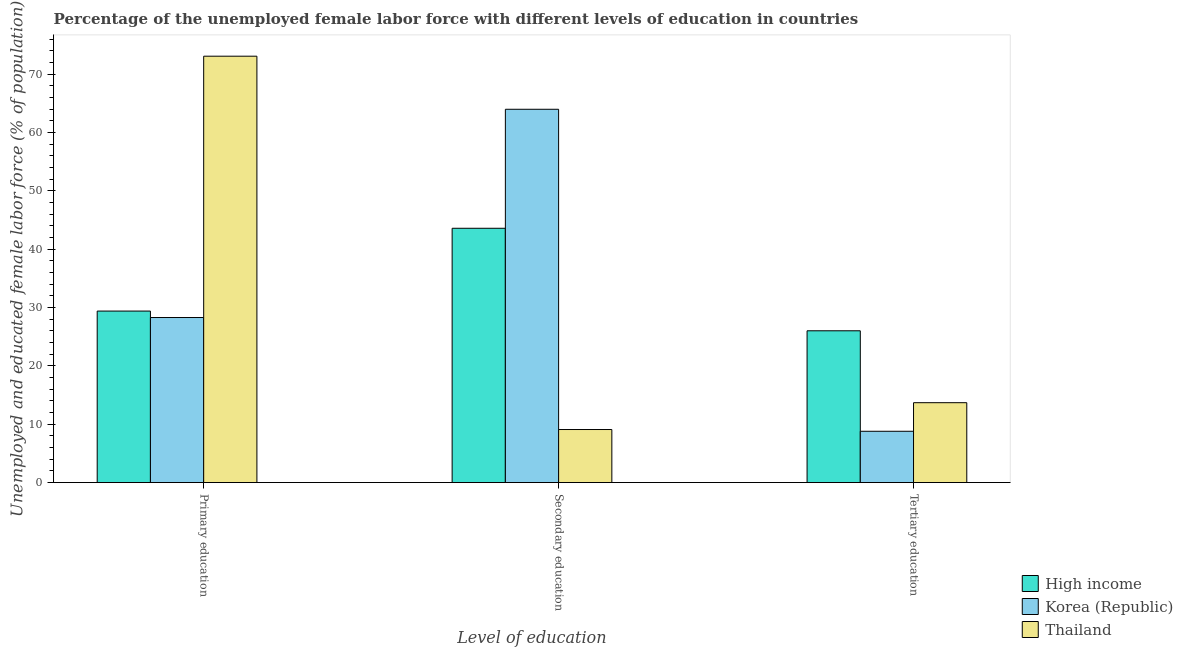How many groups of bars are there?
Your answer should be very brief. 3. How many bars are there on the 2nd tick from the left?
Your answer should be compact. 3. How many bars are there on the 2nd tick from the right?
Offer a very short reply. 3. What is the label of the 3rd group of bars from the left?
Keep it short and to the point. Tertiary education. What is the percentage of female labor force who received primary education in High income?
Offer a terse response. 29.41. Across all countries, what is the maximum percentage of female labor force who received secondary education?
Your response must be concise. 64. Across all countries, what is the minimum percentage of female labor force who received secondary education?
Provide a succinct answer. 9.1. In which country was the percentage of female labor force who received tertiary education minimum?
Keep it short and to the point. Korea (Republic). What is the total percentage of female labor force who received secondary education in the graph?
Your answer should be compact. 116.7. What is the difference between the percentage of female labor force who received secondary education in High income and that in Korea (Republic)?
Keep it short and to the point. -20.4. What is the difference between the percentage of female labor force who received tertiary education in Korea (Republic) and the percentage of female labor force who received secondary education in Thailand?
Give a very brief answer. -0.3. What is the average percentage of female labor force who received tertiary education per country?
Your response must be concise. 16.18. What is the difference between the percentage of female labor force who received secondary education and percentage of female labor force who received tertiary education in High income?
Offer a very short reply. 17.57. In how many countries, is the percentage of female labor force who received secondary education greater than 32 %?
Give a very brief answer. 2. What is the ratio of the percentage of female labor force who received tertiary education in Korea (Republic) to that in Thailand?
Offer a very short reply. 0.64. Is the percentage of female labor force who received tertiary education in Korea (Republic) less than that in High income?
Make the answer very short. Yes. What is the difference between the highest and the second highest percentage of female labor force who received secondary education?
Make the answer very short. 20.4. What is the difference between the highest and the lowest percentage of female labor force who received tertiary education?
Offer a terse response. 17.23. In how many countries, is the percentage of female labor force who received tertiary education greater than the average percentage of female labor force who received tertiary education taken over all countries?
Ensure brevity in your answer.  1. Is the sum of the percentage of female labor force who received secondary education in High income and Thailand greater than the maximum percentage of female labor force who received tertiary education across all countries?
Give a very brief answer. Yes. What does the 3rd bar from the left in Secondary education represents?
Keep it short and to the point. Thailand. How many bars are there?
Give a very brief answer. 9. Are the values on the major ticks of Y-axis written in scientific E-notation?
Your answer should be compact. No. Does the graph contain any zero values?
Make the answer very short. No. Does the graph contain grids?
Provide a succinct answer. No. How many legend labels are there?
Your response must be concise. 3. How are the legend labels stacked?
Your response must be concise. Vertical. What is the title of the graph?
Make the answer very short. Percentage of the unemployed female labor force with different levels of education in countries. Does "Jamaica" appear as one of the legend labels in the graph?
Keep it short and to the point. No. What is the label or title of the X-axis?
Offer a very short reply. Level of education. What is the label or title of the Y-axis?
Make the answer very short. Unemployed and educated female labor force (% of population). What is the Unemployed and educated female labor force (% of population) of High income in Primary education?
Keep it short and to the point. 29.41. What is the Unemployed and educated female labor force (% of population) in Korea (Republic) in Primary education?
Provide a short and direct response. 28.3. What is the Unemployed and educated female labor force (% of population) in Thailand in Primary education?
Ensure brevity in your answer.  73.1. What is the Unemployed and educated female labor force (% of population) in High income in Secondary education?
Your answer should be very brief. 43.6. What is the Unemployed and educated female labor force (% of population) of Korea (Republic) in Secondary education?
Provide a succinct answer. 64. What is the Unemployed and educated female labor force (% of population) in Thailand in Secondary education?
Ensure brevity in your answer.  9.1. What is the Unemployed and educated female labor force (% of population) of High income in Tertiary education?
Your answer should be compact. 26.03. What is the Unemployed and educated female labor force (% of population) in Korea (Republic) in Tertiary education?
Ensure brevity in your answer.  8.8. What is the Unemployed and educated female labor force (% of population) in Thailand in Tertiary education?
Offer a very short reply. 13.7. Across all Level of education, what is the maximum Unemployed and educated female labor force (% of population) of High income?
Your answer should be very brief. 43.6. Across all Level of education, what is the maximum Unemployed and educated female labor force (% of population) of Korea (Republic)?
Your response must be concise. 64. Across all Level of education, what is the maximum Unemployed and educated female labor force (% of population) in Thailand?
Keep it short and to the point. 73.1. Across all Level of education, what is the minimum Unemployed and educated female labor force (% of population) in High income?
Your response must be concise. 26.03. Across all Level of education, what is the minimum Unemployed and educated female labor force (% of population) of Korea (Republic)?
Offer a terse response. 8.8. Across all Level of education, what is the minimum Unemployed and educated female labor force (% of population) of Thailand?
Provide a short and direct response. 9.1. What is the total Unemployed and educated female labor force (% of population) of High income in the graph?
Your answer should be compact. 99.03. What is the total Unemployed and educated female labor force (% of population) of Korea (Republic) in the graph?
Provide a succinct answer. 101.1. What is the total Unemployed and educated female labor force (% of population) of Thailand in the graph?
Your response must be concise. 95.9. What is the difference between the Unemployed and educated female labor force (% of population) of High income in Primary education and that in Secondary education?
Your answer should be very brief. -14.19. What is the difference between the Unemployed and educated female labor force (% of population) in Korea (Republic) in Primary education and that in Secondary education?
Provide a succinct answer. -35.7. What is the difference between the Unemployed and educated female labor force (% of population) of Thailand in Primary education and that in Secondary education?
Offer a terse response. 64. What is the difference between the Unemployed and educated female labor force (% of population) in High income in Primary education and that in Tertiary education?
Keep it short and to the point. 3.38. What is the difference between the Unemployed and educated female labor force (% of population) in Thailand in Primary education and that in Tertiary education?
Your answer should be compact. 59.4. What is the difference between the Unemployed and educated female labor force (% of population) in High income in Secondary education and that in Tertiary education?
Your answer should be very brief. 17.57. What is the difference between the Unemployed and educated female labor force (% of population) of Korea (Republic) in Secondary education and that in Tertiary education?
Your answer should be compact. 55.2. What is the difference between the Unemployed and educated female labor force (% of population) of Thailand in Secondary education and that in Tertiary education?
Provide a short and direct response. -4.6. What is the difference between the Unemployed and educated female labor force (% of population) of High income in Primary education and the Unemployed and educated female labor force (% of population) of Korea (Republic) in Secondary education?
Your answer should be compact. -34.59. What is the difference between the Unemployed and educated female labor force (% of population) of High income in Primary education and the Unemployed and educated female labor force (% of population) of Thailand in Secondary education?
Provide a short and direct response. 20.31. What is the difference between the Unemployed and educated female labor force (% of population) of High income in Primary education and the Unemployed and educated female labor force (% of population) of Korea (Republic) in Tertiary education?
Your answer should be very brief. 20.61. What is the difference between the Unemployed and educated female labor force (% of population) in High income in Primary education and the Unemployed and educated female labor force (% of population) in Thailand in Tertiary education?
Your answer should be compact. 15.71. What is the difference between the Unemployed and educated female labor force (% of population) in Korea (Republic) in Primary education and the Unemployed and educated female labor force (% of population) in Thailand in Tertiary education?
Give a very brief answer. 14.6. What is the difference between the Unemployed and educated female labor force (% of population) in High income in Secondary education and the Unemployed and educated female labor force (% of population) in Korea (Republic) in Tertiary education?
Your answer should be very brief. 34.8. What is the difference between the Unemployed and educated female labor force (% of population) of High income in Secondary education and the Unemployed and educated female labor force (% of population) of Thailand in Tertiary education?
Your answer should be very brief. 29.9. What is the difference between the Unemployed and educated female labor force (% of population) in Korea (Republic) in Secondary education and the Unemployed and educated female labor force (% of population) in Thailand in Tertiary education?
Make the answer very short. 50.3. What is the average Unemployed and educated female labor force (% of population) in High income per Level of education?
Provide a succinct answer. 33.01. What is the average Unemployed and educated female labor force (% of population) of Korea (Republic) per Level of education?
Offer a very short reply. 33.7. What is the average Unemployed and educated female labor force (% of population) in Thailand per Level of education?
Make the answer very short. 31.97. What is the difference between the Unemployed and educated female labor force (% of population) of High income and Unemployed and educated female labor force (% of population) of Korea (Republic) in Primary education?
Make the answer very short. 1.11. What is the difference between the Unemployed and educated female labor force (% of population) in High income and Unemployed and educated female labor force (% of population) in Thailand in Primary education?
Keep it short and to the point. -43.69. What is the difference between the Unemployed and educated female labor force (% of population) in Korea (Republic) and Unemployed and educated female labor force (% of population) in Thailand in Primary education?
Offer a terse response. -44.8. What is the difference between the Unemployed and educated female labor force (% of population) of High income and Unemployed and educated female labor force (% of population) of Korea (Republic) in Secondary education?
Provide a short and direct response. -20.4. What is the difference between the Unemployed and educated female labor force (% of population) in High income and Unemployed and educated female labor force (% of population) in Thailand in Secondary education?
Your response must be concise. 34.5. What is the difference between the Unemployed and educated female labor force (% of population) of Korea (Republic) and Unemployed and educated female labor force (% of population) of Thailand in Secondary education?
Provide a short and direct response. 54.9. What is the difference between the Unemployed and educated female labor force (% of population) in High income and Unemployed and educated female labor force (% of population) in Korea (Republic) in Tertiary education?
Give a very brief answer. 17.23. What is the difference between the Unemployed and educated female labor force (% of population) in High income and Unemployed and educated female labor force (% of population) in Thailand in Tertiary education?
Your response must be concise. 12.33. What is the ratio of the Unemployed and educated female labor force (% of population) of High income in Primary education to that in Secondary education?
Make the answer very short. 0.67. What is the ratio of the Unemployed and educated female labor force (% of population) in Korea (Republic) in Primary education to that in Secondary education?
Keep it short and to the point. 0.44. What is the ratio of the Unemployed and educated female labor force (% of population) in Thailand in Primary education to that in Secondary education?
Offer a very short reply. 8.03. What is the ratio of the Unemployed and educated female labor force (% of population) in High income in Primary education to that in Tertiary education?
Give a very brief answer. 1.13. What is the ratio of the Unemployed and educated female labor force (% of population) in Korea (Republic) in Primary education to that in Tertiary education?
Your answer should be very brief. 3.22. What is the ratio of the Unemployed and educated female labor force (% of population) of Thailand in Primary education to that in Tertiary education?
Offer a terse response. 5.34. What is the ratio of the Unemployed and educated female labor force (% of population) of High income in Secondary education to that in Tertiary education?
Offer a very short reply. 1.68. What is the ratio of the Unemployed and educated female labor force (% of population) in Korea (Republic) in Secondary education to that in Tertiary education?
Give a very brief answer. 7.27. What is the ratio of the Unemployed and educated female labor force (% of population) in Thailand in Secondary education to that in Tertiary education?
Make the answer very short. 0.66. What is the difference between the highest and the second highest Unemployed and educated female labor force (% of population) in High income?
Offer a terse response. 14.19. What is the difference between the highest and the second highest Unemployed and educated female labor force (% of population) in Korea (Republic)?
Your answer should be very brief. 35.7. What is the difference between the highest and the second highest Unemployed and educated female labor force (% of population) of Thailand?
Provide a short and direct response. 59.4. What is the difference between the highest and the lowest Unemployed and educated female labor force (% of population) in High income?
Offer a terse response. 17.57. What is the difference between the highest and the lowest Unemployed and educated female labor force (% of population) of Korea (Republic)?
Ensure brevity in your answer.  55.2. 